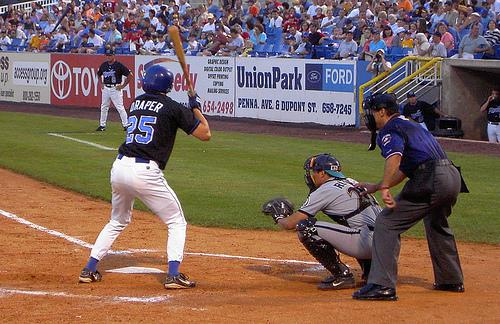Question: why is the man wearing a baseball glove?
Choices:
A. Catcher.
B. Pitcher.
C. Shortstop.
D. Outfielder.
Answer with the letter. Answer: A Question: who is holding the bat?
Choices:
A. Baseball Player.
B. Batter.
C. Catcher.
D. Umpire.
Answer with the letter. Answer: B Question: where was the picture taken?
Choices:
A. Field.
B. Baseball stadium.
C. Backyard.
D. Park.
Answer with the letter. Answer: B Question: how many people are standing on the field?
Choices:
A. Four.
B. Three.
C. Five.
D. Six.
Answer with the letter. Answer: A Question: what color are the catcher's shoes?
Choices:
A. Black.
B. White.
C. Blue.
D. Red.
Answer with the letter. Answer: A Question: who is standing behind the catcher?
Choices:
A. Coach.
B. Fans.
C. Umpire.
D. Reporter.
Answer with the letter. Answer: C 